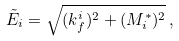<formula> <loc_0><loc_0><loc_500><loc_500>\tilde { E } _ { i } = \sqrt { ( k ^ { i } _ { f } ) ^ { 2 } + ( M ^ { * } _ { i } ) ^ { 2 } } \, ,</formula> 